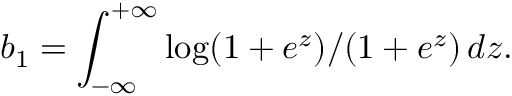Convert formula to latex. <formula><loc_0><loc_0><loc_500><loc_500>b _ { 1 } = \int _ { - \infty } ^ { + \infty } \log ( 1 + e ^ { z } ) / ( 1 + e ^ { z } ) \, d z .</formula> 